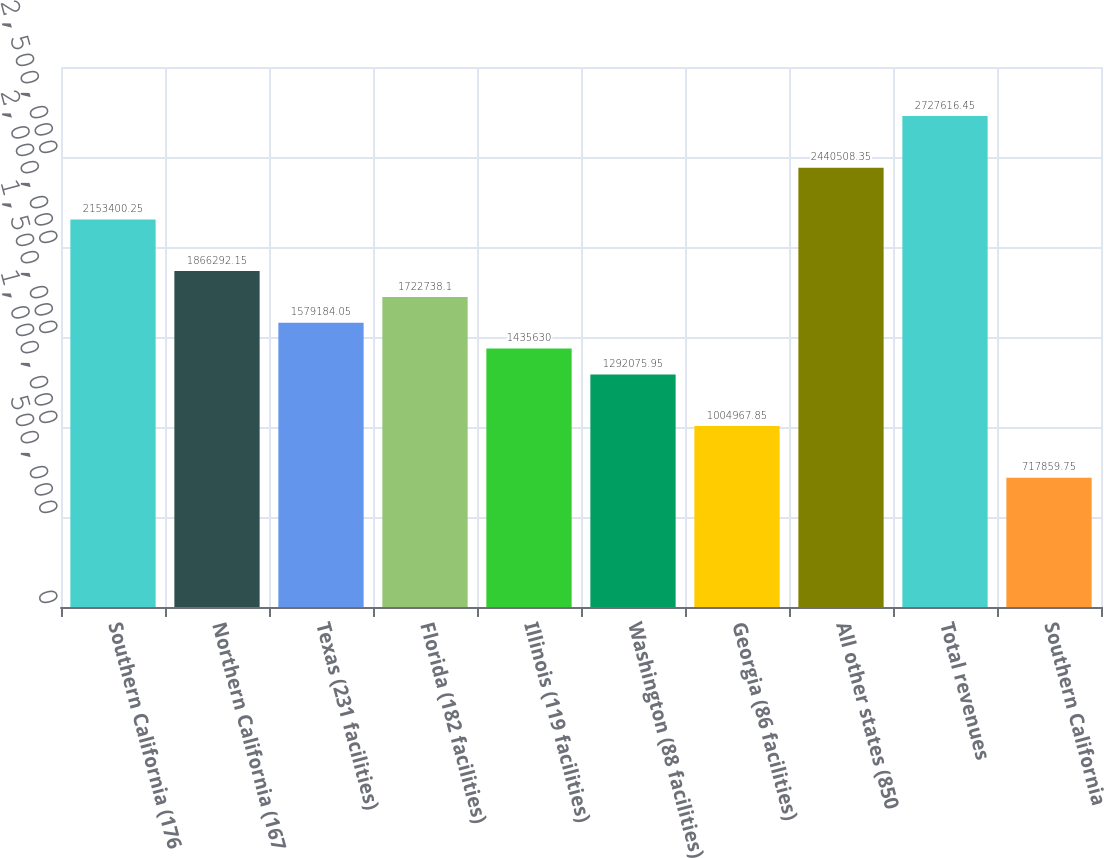Convert chart to OTSL. <chart><loc_0><loc_0><loc_500><loc_500><bar_chart><fcel>Southern California (176<fcel>Northern California (167<fcel>Texas (231 facilities)<fcel>Florida (182 facilities)<fcel>Illinois (119 facilities)<fcel>Washington (88 facilities)<fcel>Georgia (86 facilities)<fcel>All other states (850<fcel>Total revenues<fcel>Southern California<nl><fcel>2.1534e+06<fcel>1.86629e+06<fcel>1.57918e+06<fcel>1.72274e+06<fcel>1.43563e+06<fcel>1.29208e+06<fcel>1.00497e+06<fcel>2.44051e+06<fcel>2.72762e+06<fcel>717860<nl></chart> 